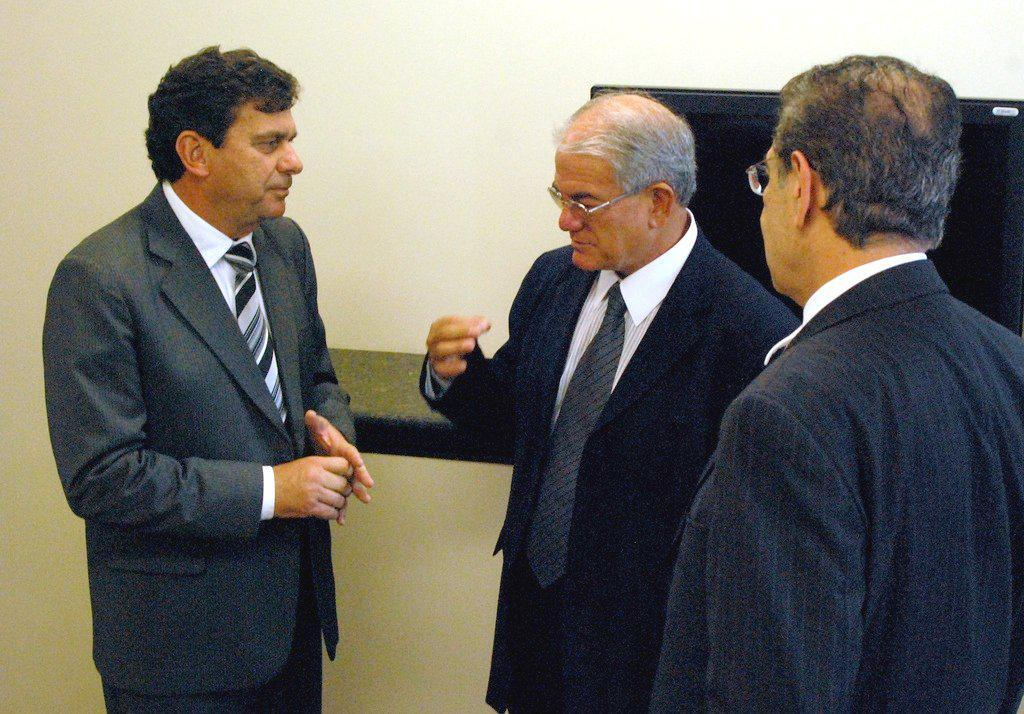What can be seen in the foreground of the image? There are men standing in the foreground of the image. What is located in the background of the image? There is a desk in the background of the image. What is on the desk in the image? There appears to be a screen on the desk. What type of wire is being used for punishment in the image? There is no wire or punishment present in the image. How does the breath of the men in the foreground affect the screen on the desk? There is no mention of the men's breath affecting the screen in the image. 